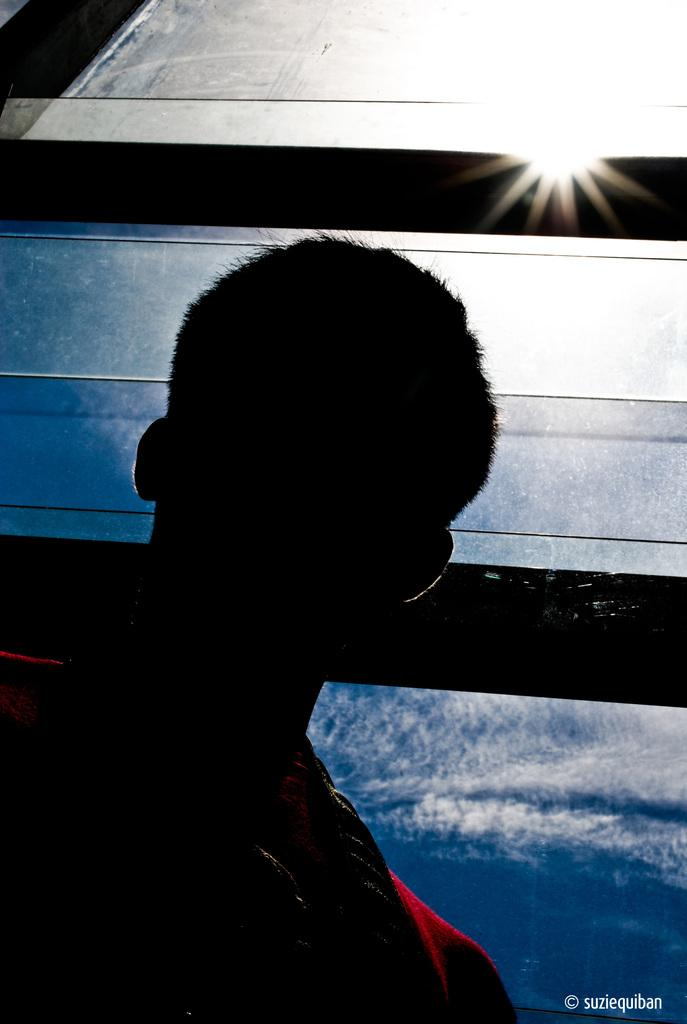Who or what is present in the image? There is a person in the image. What can be seen in the background of the image? There is glass in the background of the image. What is visible through the glass? The sky with clouds is visible through the glass. What type of motion can be observed in the image? There is no motion observed in the image; it is a still image. What is the person in the image observing? The provided facts do not specify what the person is observing in the image. 